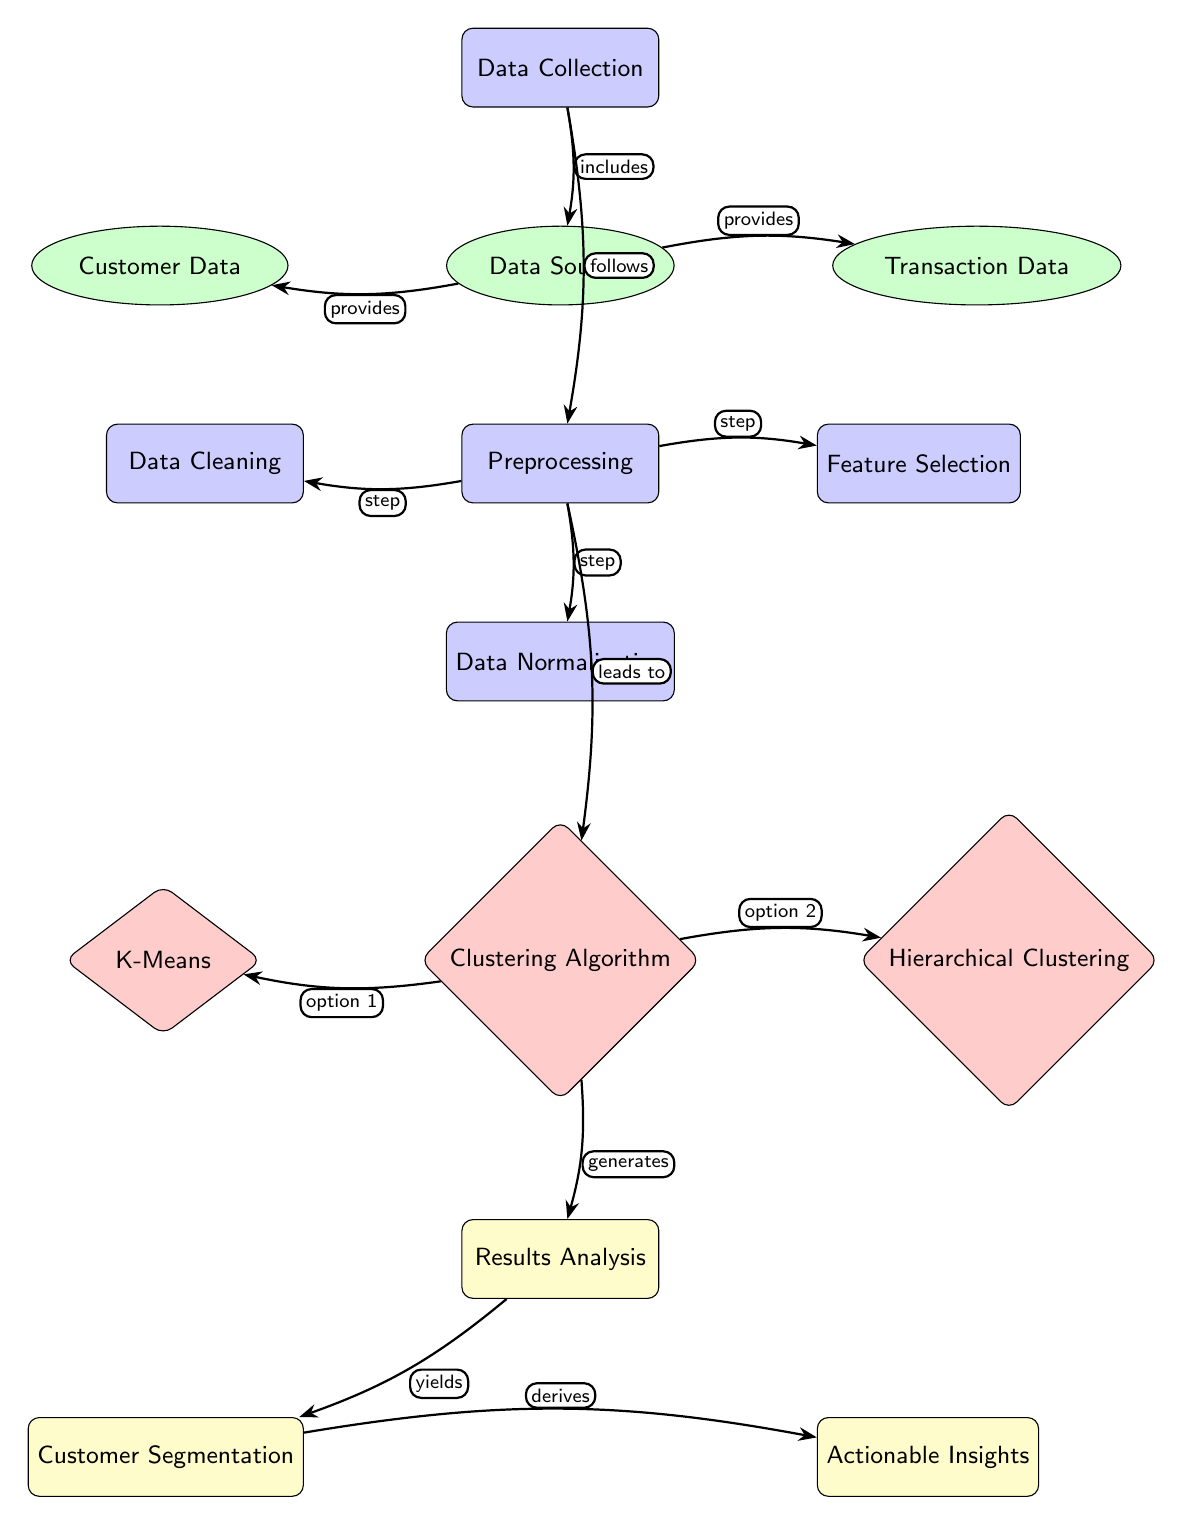What is the first process in the diagram? The diagram shows the first process labeled as "Data Collection" at the top of the flow.
Answer: Data Collection How many data sources are identified in the diagram? The diagram lists two data sources: "Customer Data" and "Transaction Data," indicating a total of two data sources.
Answer: 2 What type of algorithm is represented after preprocessing? The diagram indicates that the type of algorithm represented after preprocessing is a "Clustering Algorithm."
Answer: Clustering Algorithm Which algorithm option is on the left of the clustering algorithm? In the diagram, the algorithm option on the left is labeled "K-Means."
Answer: K-Means What is the result derived from customer segmentation? The diagram shows that the result derived from customer segmentation is "Actionable Insights."
Answer: Actionable Insights Which process directly follows data collection in the diagram? The next process that follows data collection, as depicted in the diagram, is "Preprocessing."
Answer: Preprocessing What does the process of normalization precede? The diagram shows that the process of normalization precedes the "Clustering Algorithm."
Answer: Clustering Algorithm What type of node is 'Feature Selection'? In the diagram, 'Feature Selection' is categorized as a process node, specifically a rectangle shape with rounded corners and labeled as such.
Answer: Process What action does segmenting customers lead to in the diagram? The diagram details that segmenting customers leads to generating "Actionable Insights," as indicated by the flow.
Answer: Actionable Insights 